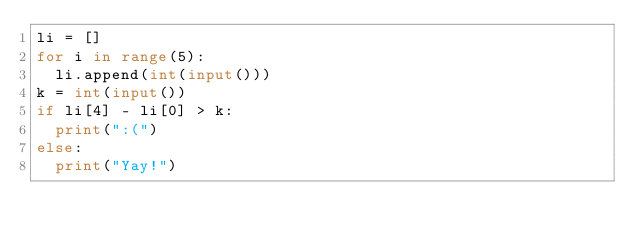Convert code to text. <code><loc_0><loc_0><loc_500><loc_500><_Python_>li = []
for i in range(5):
  li.append(int(input()))
k = int(input())
if li[4] - li[0] > k:
  print(":(")
else:
  print("Yay!")</code> 